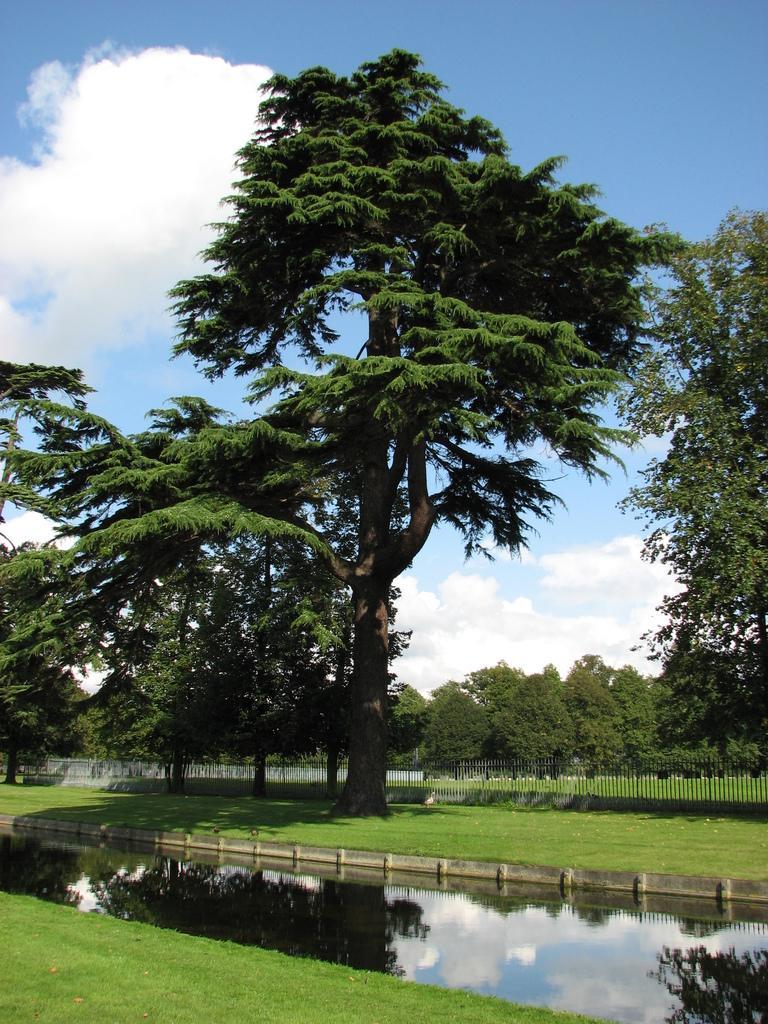Can you describe this image briefly? In this picture we can see water and grass on the ground and in the background we can see a fence, trees and sky with clouds. 